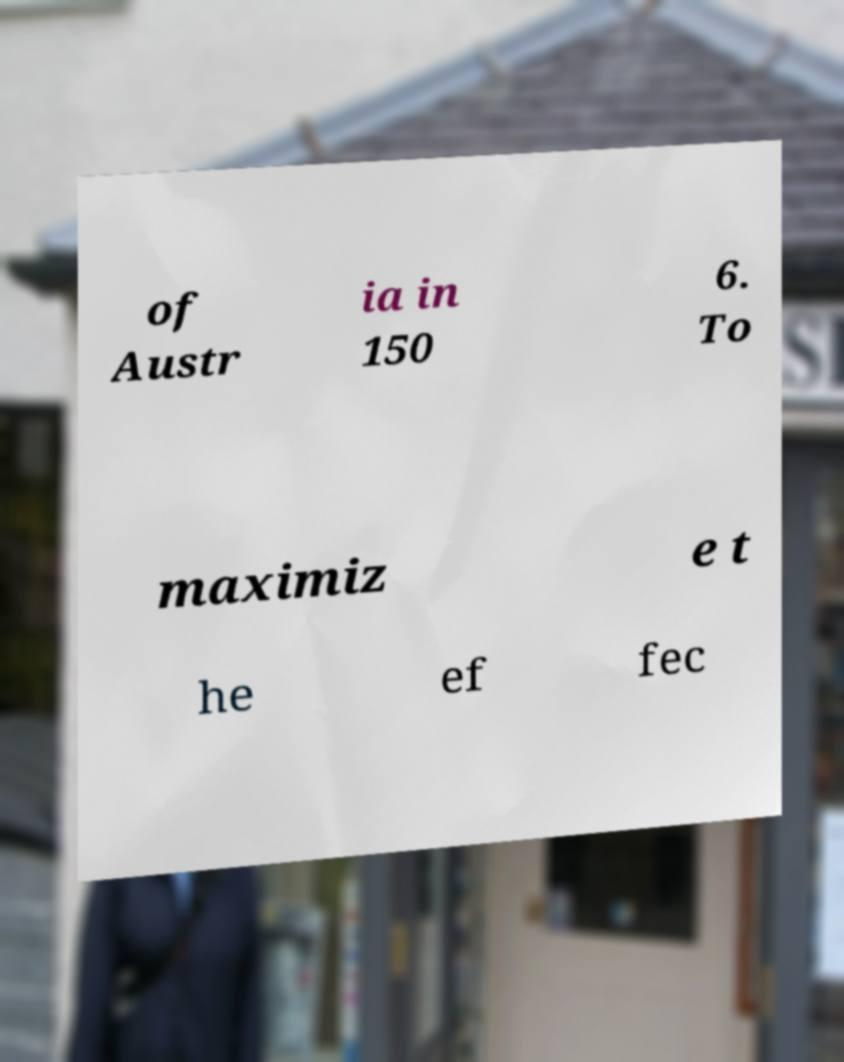For documentation purposes, I need the text within this image transcribed. Could you provide that? of Austr ia in 150 6. To maximiz e t he ef fec 